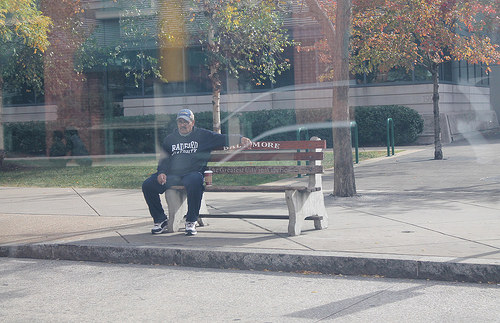<image>
Is there a bench behind the man? No. The bench is not behind the man. From this viewpoint, the bench appears to be positioned elsewhere in the scene. 